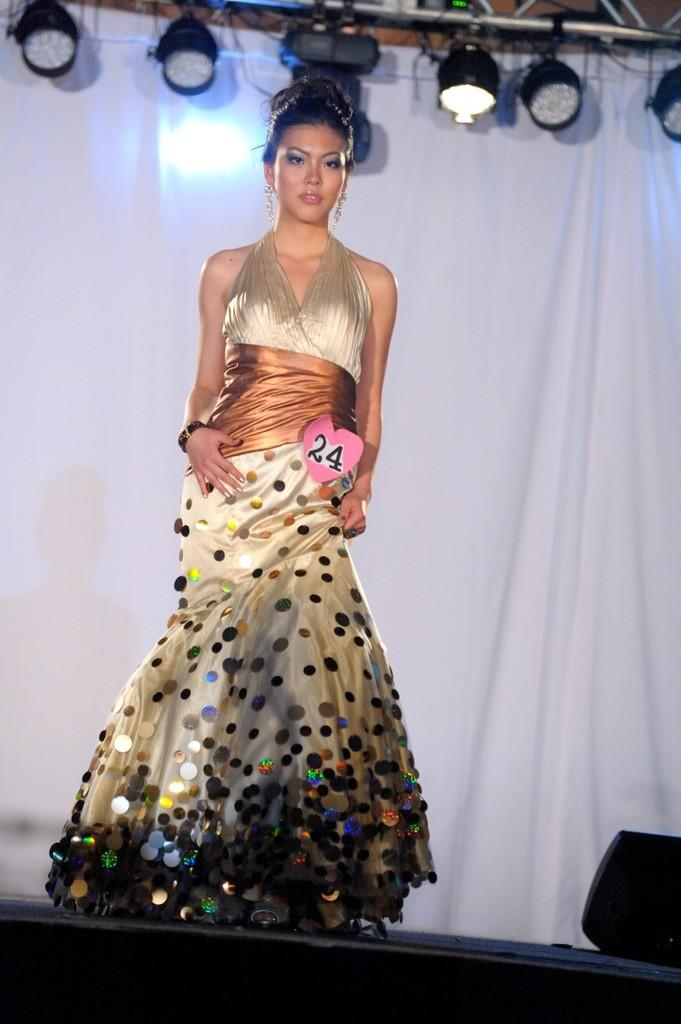What is the woman doing in the image? The woman is standing on the stage. What is located at the back of the stage? There is a curtain at the back of the stage. What can be seen at the top of the stage? There are lights at the top of the stage. What is positioned at the bottom of the stage? There is a speaker at the bottom of the stage. How many giants are visible on the stage in the image? There are no giants visible on the stage in the image. What type of drum is being played by the woman on the stage? There is no drum present in the image; the woman is not playing any musical instrument. 